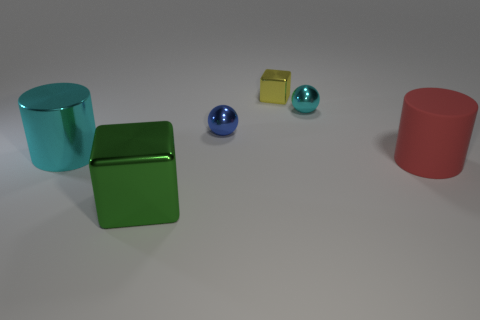What number of small cyan metal things are the same shape as the large cyan thing?
Ensure brevity in your answer.  0. The other sphere that is made of the same material as the cyan ball is what size?
Offer a terse response. Small. Are there the same number of large red objects that are behind the yellow object and cyan metallic things?
Make the answer very short. No. Do the large rubber thing and the big metal block have the same color?
Keep it short and to the point. No. There is a thing on the left side of the large cube; does it have the same shape as the big metal thing that is in front of the shiny cylinder?
Provide a short and direct response. No. There is another tiny object that is the same shape as the green thing; what is its material?
Offer a terse response. Metal. What color is the shiny object that is in front of the tiny blue object and behind the green shiny object?
Provide a succinct answer. Cyan. Are there any blocks that are right of the metallic sphere in front of the cyan shiny thing that is to the right of the green shiny block?
Give a very brief answer. Yes. What number of objects are big cyan metallic cylinders or big purple metallic balls?
Provide a short and direct response. 1. Does the big green object have the same material as the cylinder that is in front of the big cyan shiny cylinder?
Your answer should be very brief. No. 